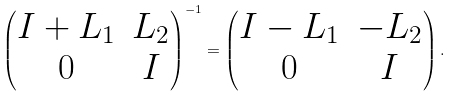Convert formula to latex. <formula><loc_0><loc_0><loc_500><loc_500>\begin{pmatrix} I + L _ { 1 } & L _ { 2 } \\ 0 & I \end{pmatrix} ^ { - 1 } = \begin{pmatrix} I - L _ { 1 } & - L _ { 2 } \\ 0 & I \end{pmatrix} .</formula> 